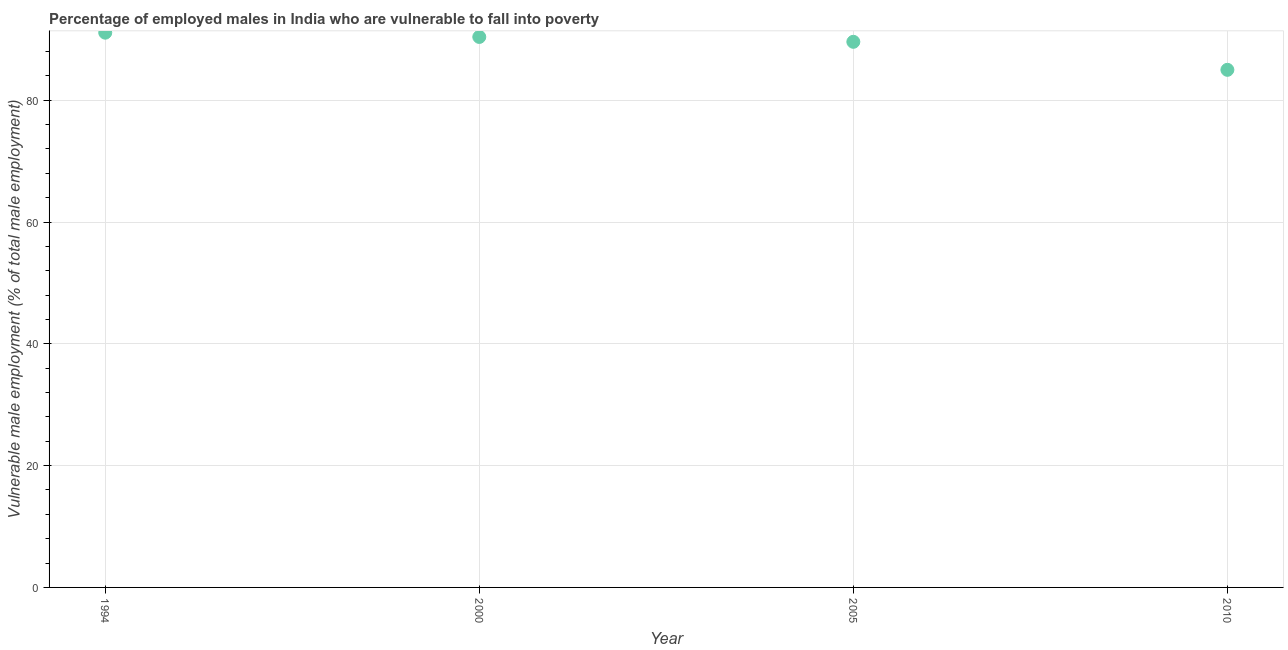What is the percentage of employed males who are vulnerable to fall into poverty in 2005?
Keep it short and to the point. 89.6. Across all years, what is the maximum percentage of employed males who are vulnerable to fall into poverty?
Your response must be concise. 91.1. Across all years, what is the minimum percentage of employed males who are vulnerable to fall into poverty?
Offer a very short reply. 85. In which year was the percentage of employed males who are vulnerable to fall into poverty maximum?
Your response must be concise. 1994. What is the sum of the percentage of employed males who are vulnerable to fall into poverty?
Provide a short and direct response. 356.1. What is the difference between the percentage of employed males who are vulnerable to fall into poverty in 2005 and 2010?
Ensure brevity in your answer.  4.6. What is the average percentage of employed males who are vulnerable to fall into poverty per year?
Provide a succinct answer. 89.02. What is the median percentage of employed males who are vulnerable to fall into poverty?
Your response must be concise. 90. In how many years, is the percentage of employed males who are vulnerable to fall into poverty greater than 52 %?
Ensure brevity in your answer.  4. What is the ratio of the percentage of employed males who are vulnerable to fall into poverty in 1994 to that in 2000?
Your response must be concise. 1.01. Is the difference between the percentage of employed males who are vulnerable to fall into poverty in 1994 and 2010 greater than the difference between any two years?
Give a very brief answer. Yes. What is the difference between the highest and the second highest percentage of employed males who are vulnerable to fall into poverty?
Give a very brief answer. 0.7. Is the sum of the percentage of employed males who are vulnerable to fall into poverty in 1994 and 2000 greater than the maximum percentage of employed males who are vulnerable to fall into poverty across all years?
Keep it short and to the point. Yes. What is the difference between the highest and the lowest percentage of employed males who are vulnerable to fall into poverty?
Keep it short and to the point. 6.1. Does the percentage of employed males who are vulnerable to fall into poverty monotonically increase over the years?
Offer a terse response. No. Does the graph contain any zero values?
Your answer should be very brief. No. Does the graph contain grids?
Your response must be concise. Yes. What is the title of the graph?
Give a very brief answer. Percentage of employed males in India who are vulnerable to fall into poverty. What is the label or title of the Y-axis?
Provide a short and direct response. Vulnerable male employment (% of total male employment). What is the Vulnerable male employment (% of total male employment) in 1994?
Offer a very short reply. 91.1. What is the Vulnerable male employment (% of total male employment) in 2000?
Your response must be concise. 90.4. What is the Vulnerable male employment (% of total male employment) in 2005?
Keep it short and to the point. 89.6. What is the difference between the Vulnerable male employment (% of total male employment) in 1994 and 2010?
Your response must be concise. 6.1. What is the difference between the Vulnerable male employment (% of total male employment) in 2005 and 2010?
Offer a very short reply. 4.6. What is the ratio of the Vulnerable male employment (% of total male employment) in 1994 to that in 2005?
Ensure brevity in your answer.  1.02. What is the ratio of the Vulnerable male employment (% of total male employment) in 1994 to that in 2010?
Your answer should be very brief. 1.07. What is the ratio of the Vulnerable male employment (% of total male employment) in 2000 to that in 2005?
Ensure brevity in your answer.  1.01. What is the ratio of the Vulnerable male employment (% of total male employment) in 2000 to that in 2010?
Ensure brevity in your answer.  1.06. What is the ratio of the Vulnerable male employment (% of total male employment) in 2005 to that in 2010?
Ensure brevity in your answer.  1.05. 